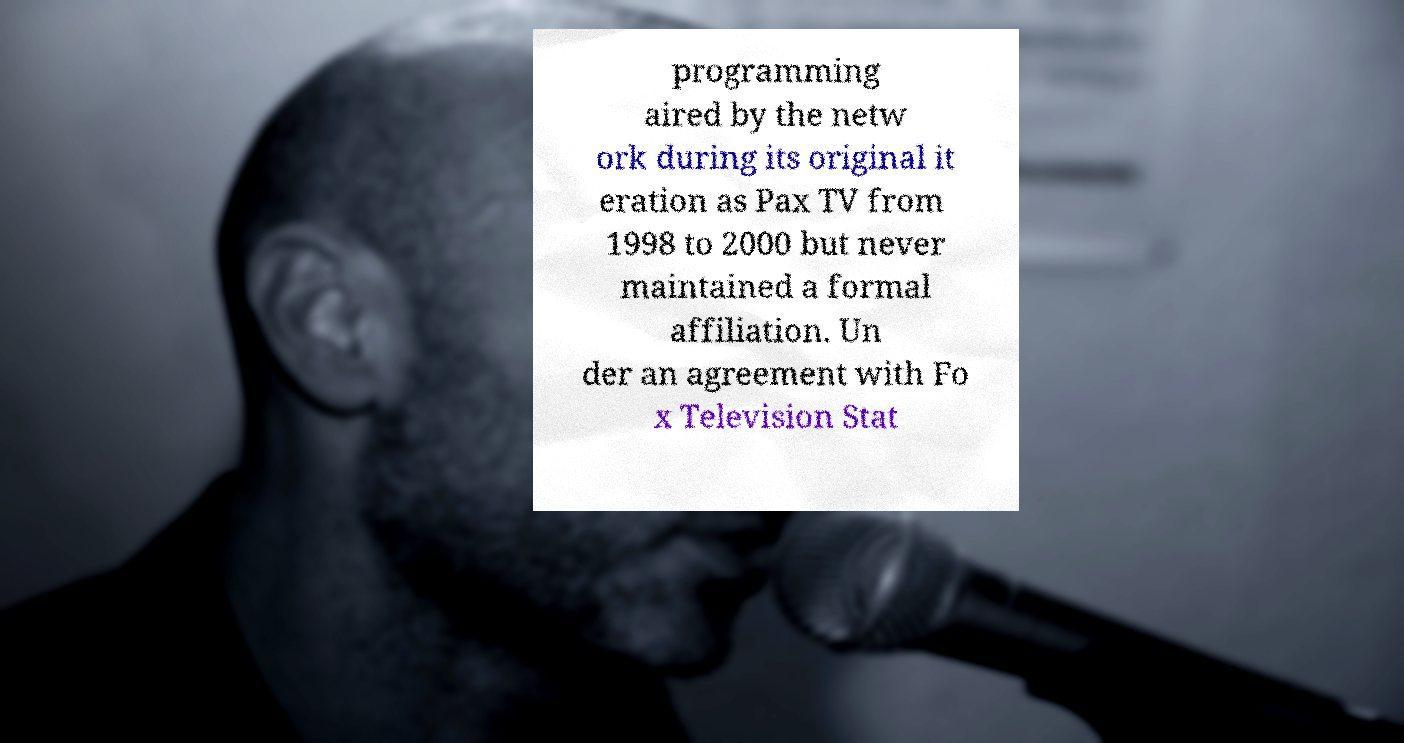There's text embedded in this image that I need extracted. Can you transcribe it verbatim? programming aired by the netw ork during its original it eration as Pax TV from 1998 to 2000 but never maintained a formal affiliation. Un der an agreement with Fo x Television Stat 